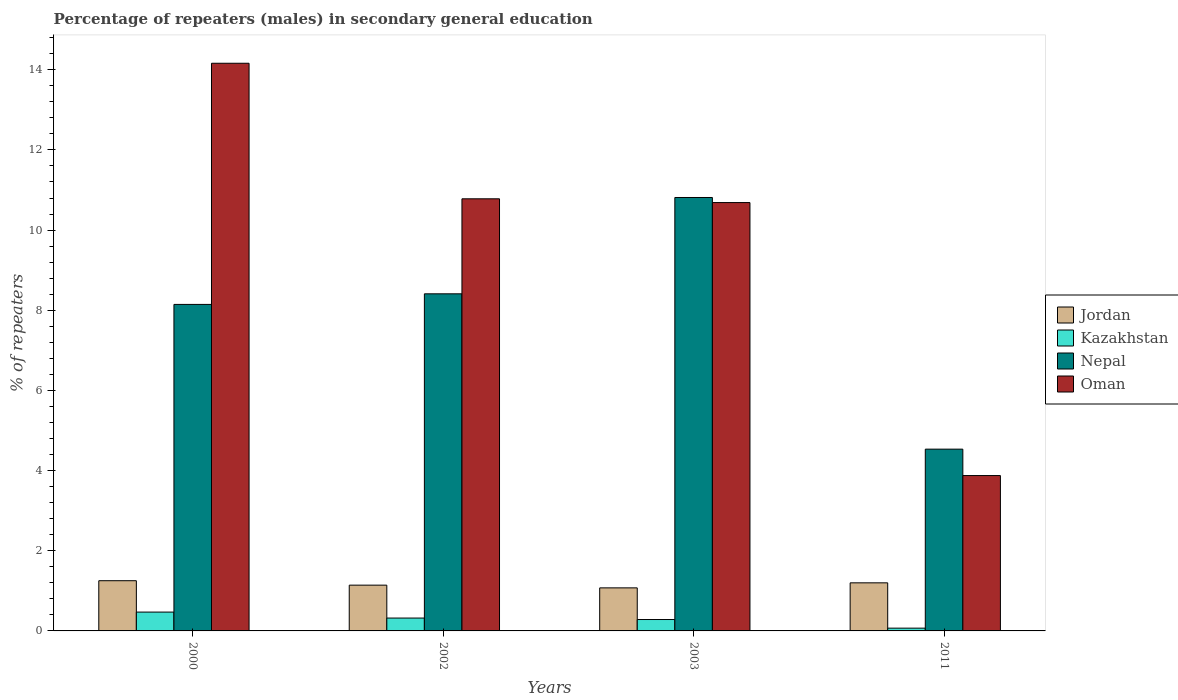How many groups of bars are there?
Ensure brevity in your answer.  4. Are the number of bars on each tick of the X-axis equal?
Keep it short and to the point. Yes. In how many cases, is the number of bars for a given year not equal to the number of legend labels?
Provide a short and direct response. 0. What is the percentage of male repeaters in Jordan in 2002?
Provide a short and direct response. 1.14. Across all years, what is the maximum percentage of male repeaters in Nepal?
Make the answer very short. 10.81. Across all years, what is the minimum percentage of male repeaters in Jordan?
Provide a short and direct response. 1.07. In which year was the percentage of male repeaters in Oman minimum?
Give a very brief answer. 2011. What is the total percentage of male repeaters in Kazakhstan in the graph?
Ensure brevity in your answer.  1.14. What is the difference between the percentage of male repeaters in Jordan in 2003 and that in 2011?
Provide a succinct answer. -0.13. What is the difference between the percentage of male repeaters in Nepal in 2003 and the percentage of male repeaters in Kazakhstan in 2002?
Your answer should be very brief. 10.49. What is the average percentage of male repeaters in Jordan per year?
Your response must be concise. 1.17. In the year 2003, what is the difference between the percentage of male repeaters in Jordan and percentage of male repeaters in Kazakhstan?
Provide a succinct answer. 0.79. In how many years, is the percentage of male repeaters in Jordan greater than 7.6 %?
Your response must be concise. 0. What is the ratio of the percentage of male repeaters in Kazakhstan in 2000 to that in 2011?
Give a very brief answer. 6.8. Is the difference between the percentage of male repeaters in Jordan in 2002 and 2003 greater than the difference between the percentage of male repeaters in Kazakhstan in 2002 and 2003?
Ensure brevity in your answer.  Yes. What is the difference between the highest and the second highest percentage of male repeaters in Oman?
Your answer should be very brief. 3.38. What is the difference between the highest and the lowest percentage of male repeaters in Oman?
Offer a terse response. 10.29. In how many years, is the percentage of male repeaters in Kazakhstan greater than the average percentage of male repeaters in Kazakhstan taken over all years?
Provide a succinct answer. 2. What does the 4th bar from the left in 2002 represents?
Give a very brief answer. Oman. What does the 1st bar from the right in 2000 represents?
Offer a very short reply. Oman. Is it the case that in every year, the sum of the percentage of male repeaters in Jordan and percentage of male repeaters in Nepal is greater than the percentage of male repeaters in Oman?
Your answer should be compact. No. How many bars are there?
Ensure brevity in your answer.  16. How many years are there in the graph?
Give a very brief answer. 4. What is the difference between two consecutive major ticks on the Y-axis?
Give a very brief answer. 2. Does the graph contain any zero values?
Ensure brevity in your answer.  No. Where does the legend appear in the graph?
Keep it short and to the point. Center right. How are the legend labels stacked?
Your answer should be compact. Vertical. What is the title of the graph?
Provide a short and direct response. Percentage of repeaters (males) in secondary general education. Does "Qatar" appear as one of the legend labels in the graph?
Your response must be concise. No. What is the label or title of the Y-axis?
Your response must be concise. % of repeaters. What is the % of repeaters in Jordan in 2000?
Keep it short and to the point. 1.25. What is the % of repeaters of Kazakhstan in 2000?
Your response must be concise. 0.47. What is the % of repeaters of Nepal in 2000?
Keep it short and to the point. 8.15. What is the % of repeaters in Oman in 2000?
Ensure brevity in your answer.  14.16. What is the % of repeaters in Jordan in 2002?
Offer a terse response. 1.14. What is the % of repeaters of Kazakhstan in 2002?
Offer a very short reply. 0.32. What is the % of repeaters of Nepal in 2002?
Your response must be concise. 8.41. What is the % of repeaters of Oman in 2002?
Make the answer very short. 10.78. What is the % of repeaters of Jordan in 2003?
Offer a very short reply. 1.07. What is the % of repeaters in Kazakhstan in 2003?
Your answer should be very brief. 0.28. What is the % of repeaters in Nepal in 2003?
Your answer should be compact. 10.81. What is the % of repeaters in Oman in 2003?
Make the answer very short. 10.69. What is the % of repeaters of Jordan in 2011?
Ensure brevity in your answer.  1.2. What is the % of repeaters of Kazakhstan in 2011?
Make the answer very short. 0.07. What is the % of repeaters in Nepal in 2011?
Make the answer very short. 4.53. What is the % of repeaters of Oman in 2011?
Ensure brevity in your answer.  3.88. Across all years, what is the maximum % of repeaters of Jordan?
Your answer should be compact. 1.25. Across all years, what is the maximum % of repeaters of Kazakhstan?
Keep it short and to the point. 0.47. Across all years, what is the maximum % of repeaters of Nepal?
Keep it short and to the point. 10.81. Across all years, what is the maximum % of repeaters of Oman?
Make the answer very short. 14.16. Across all years, what is the minimum % of repeaters of Jordan?
Keep it short and to the point. 1.07. Across all years, what is the minimum % of repeaters of Kazakhstan?
Ensure brevity in your answer.  0.07. Across all years, what is the minimum % of repeaters of Nepal?
Offer a very short reply. 4.53. Across all years, what is the minimum % of repeaters in Oman?
Provide a short and direct response. 3.88. What is the total % of repeaters of Jordan in the graph?
Ensure brevity in your answer.  4.67. What is the total % of repeaters of Kazakhstan in the graph?
Keep it short and to the point. 1.14. What is the total % of repeaters in Nepal in the graph?
Offer a very short reply. 31.9. What is the total % of repeaters in Oman in the graph?
Offer a terse response. 39.51. What is the difference between the % of repeaters of Jordan in 2000 and that in 2002?
Your answer should be compact. 0.11. What is the difference between the % of repeaters in Kazakhstan in 2000 and that in 2002?
Provide a succinct answer. 0.15. What is the difference between the % of repeaters of Nepal in 2000 and that in 2002?
Your answer should be compact. -0.26. What is the difference between the % of repeaters in Oman in 2000 and that in 2002?
Give a very brief answer. 3.38. What is the difference between the % of repeaters of Jordan in 2000 and that in 2003?
Your response must be concise. 0.18. What is the difference between the % of repeaters in Kazakhstan in 2000 and that in 2003?
Provide a short and direct response. 0.19. What is the difference between the % of repeaters in Nepal in 2000 and that in 2003?
Offer a terse response. -2.67. What is the difference between the % of repeaters in Oman in 2000 and that in 2003?
Ensure brevity in your answer.  3.48. What is the difference between the % of repeaters of Jordan in 2000 and that in 2011?
Your response must be concise. 0.05. What is the difference between the % of repeaters of Kazakhstan in 2000 and that in 2011?
Keep it short and to the point. 0.4. What is the difference between the % of repeaters in Nepal in 2000 and that in 2011?
Give a very brief answer. 3.61. What is the difference between the % of repeaters of Oman in 2000 and that in 2011?
Offer a very short reply. 10.29. What is the difference between the % of repeaters of Jordan in 2002 and that in 2003?
Your answer should be very brief. 0.07. What is the difference between the % of repeaters of Kazakhstan in 2002 and that in 2003?
Ensure brevity in your answer.  0.04. What is the difference between the % of repeaters of Nepal in 2002 and that in 2003?
Provide a short and direct response. -2.4. What is the difference between the % of repeaters in Oman in 2002 and that in 2003?
Your answer should be very brief. 0.09. What is the difference between the % of repeaters in Jordan in 2002 and that in 2011?
Make the answer very short. -0.06. What is the difference between the % of repeaters of Kazakhstan in 2002 and that in 2011?
Offer a terse response. 0.25. What is the difference between the % of repeaters in Nepal in 2002 and that in 2011?
Provide a succinct answer. 3.88. What is the difference between the % of repeaters in Oman in 2002 and that in 2011?
Provide a succinct answer. 6.9. What is the difference between the % of repeaters in Jordan in 2003 and that in 2011?
Provide a succinct answer. -0.13. What is the difference between the % of repeaters of Kazakhstan in 2003 and that in 2011?
Provide a short and direct response. 0.22. What is the difference between the % of repeaters in Nepal in 2003 and that in 2011?
Your response must be concise. 6.28. What is the difference between the % of repeaters in Oman in 2003 and that in 2011?
Give a very brief answer. 6.81. What is the difference between the % of repeaters of Jordan in 2000 and the % of repeaters of Kazakhstan in 2002?
Offer a very short reply. 0.93. What is the difference between the % of repeaters of Jordan in 2000 and the % of repeaters of Nepal in 2002?
Your answer should be compact. -7.16. What is the difference between the % of repeaters in Jordan in 2000 and the % of repeaters in Oman in 2002?
Your answer should be very brief. -9.53. What is the difference between the % of repeaters of Kazakhstan in 2000 and the % of repeaters of Nepal in 2002?
Offer a terse response. -7.94. What is the difference between the % of repeaters of Kazakhstan in 2000 and the % of repeaters of Oman in 2002?
Your answer should be compact. -10.31. What is the difference between the % of repeaters in Nepal in 2000 and the % of repeaters in Oman in 2002?
Ensure brevity in your answer.  -2.63. What is the difference between the % of repeaters in Jordan in 2000 and the % of repeaters in Kazakhstan in 2003?
Give a very brief answer. 0.97. What is the difference between the % of repeaters of Jordan in 2000 and the % of repeaters of Nepal in 2003?
Ensure brevity in your answer.  -9.56. What is the difference between the % of repeaters in Jordan in 2000 and the % of repeaters in Oman in 2003?
Your answer should be compact. -9.43. What is the difference between the % of repeaters in Kazakhstan in 2000 and the % of repeaters in Nepal in 2003?
Keep it short and to the point. -10.34. What is the difference between the % of repeaters in Kazakhstan in 2000 and the % of repeaters in Oman in 2003?
Keep it short and to the point. -10.22. What is the difference between the % of repeaters in Nepal in 2000 and the % of repeaters in Oman in 2003?
Provide a succinct answer. -2.54. What is the difference between the % of repeaters in Jordan in 2000 and the % of repeaters in Kazakhstan in 2011?
Your answer should be compact. 1.18. What is the difference between the % of repeaters of Jordan in 2000 and the % of repeaters of Nepal in 2011?
Offer a terse response. -3.28. What is the difference between the % of repeaters in Jordan in 2000 and the % of repeaters in Oman in 2011?
Give a very brief answer. -2.62. What is the difference between the % of repeaters of Kazakhstan in 2000 and the % of repeaters of Nepal in 2011?
Keep it short and to the point. -4.06. What is the difference between the % of repeaters of Kazakhstan in 2000 and the % of repeaters of Oman in 2011?
Give a very brief answer. -3.41. What is the difference between the % of repeaters of Nepal in 2000 and the % of repeaters of Oman in 2011?
Offer a very short reply. 4.27. What is the difference between the % of repeaters of Jordan in 2002 and the % of repeaters of Kazakhstan in 2003?
Make the answer very short. 0.86. What is the difference between the % of repeaters of Jordan in 2002 and the % of repeaters of Nepal in 2003?
Your response must be concise. -9.67. What is the difference between the % of repeaters in Jordan in 2002 and the % of repeaters in Oman in 2003?
Your answer should be compact. -9.54. What is the difference between the % of repeaters in Kazakhstan in 2002 and the % of repeaters in Nepal in 2003?
Give a very brief answer. -10.49. What is the difference between the % of repeaters of Kazakhstan in 2002 and the % of repeaters of Oman in 2003?
Provide a short and direct response. -10.37. What is the difference between the % of repeaters in Nepal in 2002 and the % of repeaters in Oman in 2003?
Your answer should be compact. -2.28. What is the difference between the % of repeaters in Jordan in 2002 and the % of repeaters in Kazakhstan in 2011?
Give a very brief answer. 1.07. What is the difference between the % of repeaters of Jordan in 2002 and the % of repeaters of Nepal in 2011?
Give a very brief answer. -3.39. What is the difference between the % of repeaters in Jordan in 2002 and the % of repeaters in Oman in 2011?
Keep it short and to the point. -2.73. What is the difference between the % of repeaters of Kazakhstan in 2002 and the % of repeaters of Nepal in 2011?
Your answer should be very brief. -4.21. What is the difference between the % of repeaters in Kazakhstan in 2002 and the % of repeaters in Oman in 2011?
Offer a terse response. -3.56. What is the difference between the % of repeaters in Nepal in 2002 and the % of repeaters in Oman in 2011?
Your answer should be very brief. 4.53. What is the difference between the % of repeaters in Jordan in 2003 and the % of repeaters in Kazakhstan in 2011?
Keep it short and to the point. 1. What is the difference between the % of repeaters in Jordan in 2003 and the % of repeaters in Nepal in 2011?
Keep it short and to the point. -3.46. What is the difference between the % of repeaters in Jordan in 2003 and the % of repeaters in Oman in 2011?
Offer a terse response. -2.8. What is the difference between the % of repeaters in Kazakhstan in 2003 and the % of repeaters in Nepal in 2011?
Your response must be concise. -4.25. What is the difference between the % of repeaters of Kazakhstan in 2003 and the % of repeaters of Oman in 2011?
Offer a terse response. -3.59. What is the difference between the % of repeaters in Nepal in 2003 and the % of repeaters in Oman in 2011?
Give a very brief answer. 6.94. What is the average % of repeaters in Jordan per year?
Offer a very short reply. 1.17. What is the average % of repeaters of Kazakhstan per year?
Offer a very short reply. 0.29. What is the average % of repeaters of Nepal per year?
Make the answer very short. 7.98. What is the average % of repeaters in Oman per year?
Ensure brevity in your answer.  9.88. In the year 2000, what is the difference between the % of repeaters of Jordan and % of repeaters of Kazakhstan?
Your answer should be very brief. 0.78. In the year 2000, what is the difference between the % of repeaters in Jordan and % of repeaters in Nepal?
Provide a succinct answer. -6.89. In the year 2000, what is the difference between the % of repeaters of Jordan and % of repeaters of Oman?
Offer a very short reply. -12.91. In the year 2000, what is the difference between the % of repeaters of Kazakhstan and % of repeaters of Nepal?
Provide a short and direct response. -7.68. In the year 2000, what is the difference between the % of repeaters of Kazakhstan and % of repeaters of Oman?
Keep it short and to the point. -13.69. In the year 2000, what is the difference between the % of repeaters in Nepal and % of repeaters in Oman?
Offer a terse response. -6.02. In the year 2002, what is the difference between the % of repeaters of Jordan and % of repeaters of Kazakhstan?
Make the answer very short. 0.82. In the year 2002, what is the difference between the % of repeaters in Jordan and % of repeaters in Nepal?
Give a very brief answer. -7.27. In the year 2002, what is the difference between the % of repeaters of Jordan and % of repeaters of Oman?
Your answer should be very brief. -9.64. In the year 2002, what is the difference between the % of repeaters in Kazakhstan and % of repeaters in Nepal?
Provide a succinct answer. -8.09. In the year 2002, what is the difference between the % of repeaters in Kazakhstan and % of repeaters in Oman?
Make the answer very short. -10.46. In the year 2002, what is the difference between the % of repeaters in Nepal and % of repeaters in Oman?
Keep it short and to the point. -2.37. In the year 2003, what is the difference between the % of repeaters in Jordan and % of repeaters in Kazakhstan?
Make the answer very short. 0.79. In the year 2003, what is the difference between the % of repeaters in Jordan and % of repeaters in Nepal?
Your answer should be very brief. -9.74. In the year 2003, what is the difference between the % of repeaters of Jordan and % of repeaters of Oman?
Your answer should be compact. -9.61. In the year 2003, what is the difference between the % of repeaters in Kazakhstan and % of repeaters in Nepal?
Keep it short and to the point. -10.53. In the year 2003, what is the difference between the % of repeaters of Kazakhstan and % of repeaters of Oman?
Your answer should be very brief. -10.4. In the year 2003, what is the difference between the % of repeaters in Nepal and % of repeaters in Oman?
Give a very brief answer. 0.13. In the year 2011, what is the difference between the % of repeaters in Jordan and % of repeaters in Kazakhstan?
Offer a very short reply. 1.13. In the year 2011, what is the difference between the % of repeaters of Jordan and % of repeaters of Nepal?
Your response must be concise. -3.34. In the year 2011, what is the difference between the % of repeaters of Jordan and % of repeaters of Oman?
Keep it short and to the point. -2.68. In the year 2011, what is the difference between the % of repeaters of Kazakhstan and % of repeaters of Nepal?
Offer a very short reply. -4.47. In the year 2011, what is the difference between the % of repeaters of Kazakhstan and % of repeaters of Oman?
Offer a terse response. -3.81. In the year 2011, what is the difference between the % of repeaters in Nepal and % of repeaters in Oman?
Provide a short and direct response. 0.66. What is the ratio of the % of repeaters of Jordan in 2000 to that in 2002?
Provide a short and direct response. 1.1. What is the ratio of the % of repeaters in Kazakhstan in 2000 to that in 2002?
Offer a terse response. 1.46. What is the ratio of the % of repeaters in Nepal in 2000 to that in 2002?
Ensure brevity in your answer.  0.97. What is the ratio of the % of repeaters in Oman in 2000 to that in 2002?
Ensure brevity in your answer.  1.31. What is the ratio of the % of repeaters of Jordan in 2000 to that in 2003?
Your answer should be very brief. 1.17. What is the ratio of the % of repeaters in Kazakhstan in 2000 to that in 2003?
Make the answer very short. 1.65. What is the ratio of the % of repeaters of Nepal in 2000 to that in 2003?
Your answer should be compact. 0.75. What is the ratio of the % of repeaters in Oman in 2000 to that in 2003?
Offer a very short reply. 1.33. What is the ratio of the % of repeaters of Jordan in 2000 to that in 2011?
Give a very brief answer. 1.04. What is the ratio of the % of repeaters in Kazakhstan in 2000 to that in 2011?
Give a very brief answer. 6.8. What is the ratio of the % of repeaters of Nepal in 2000 to that in 2011?
Provide a succinct answer. 1.8. What is the ratio of the % of repeaters of Oman in 2000 to that in 2011?
Provide a succinct answer. 3.65. What is the ratio of the % of repeaters in Jordan in 2002 to that in 2003?
Your answer should be very brief. 1.06. What is the ratio of the % of repeaters of Kazakhstan in 2002 to that in 2003?
Give a very brief answer. 1.13. What is the ratio of the % of repeaters of Nepal in 2002 to that in 2003?
Provide a succinct answer. 0.78. What is the ratio of the % of repeaters of Oman in 2002 to that in 2003?
Make the answer very short. 1.01. What is the ratio of the % of repeaters of Jordan in 2002 to that in 2011?
Provide a succinct answer. 0.95. What is the ratio of the % of repeaters in Kazakhstan in 2002 to that in 2011?
Your answer should be very brief. 4.64. What is the ratio of the % of repeaters of Nepal in 2002 to that in 2011?
Provide a succinct answer. 1.85. What is the ratio of the % of repeaters of Oman in 2002 to that in 2011?
Ensure brevity in your answer.  2.78. What is the ratio of the % of repeaters in Jordan in 2003 to that in 2011?
Provide a short and direct response. 0.9. What is the ratio of the % of repeaters of Kazakhstan in 2003 to that in 2011?
Ensure brevity in your answer.  4.11. What is the ratio of the % of repeaters in Nepal in 2003 to that in 2011?
Your answer should be very brief. 2.38. What is the ratio of the % of repeaters in Oman in 2003 to that in 2011?
Ensure brevity in your answer.  2.76. What is the difference between the highest and the second highest % of repeaters in Jordan?
Provide a succinct answer. 0.05. What is the difference between the highest and the second highest % of repeaters of Kazakhstan?
Ensure brevity in your answer.  0.15. What is the difference between the highest and the second highest % of repeaters of Nepal?
Make the answer very short. 2.4. What is the difference between the highest and the second highest % of repeaters in Oman?
Offer a terse response. 3.38. What is the difference between the highest and the lowest % of repeaters of Jordan?
Provide a short and direct response. 0.18. What is the difference between the highest and the lowest % of repeaters of Kazakhstan?
Your response must be concise. 0.4. What is the difference between the highest and the lowest % of repeaters of Nepal?
Keep it short and to the point. 6.28. What is the difference between the highest and the lowest % of repeaters of Oman?
Your answer should be very brief. 10.29. 